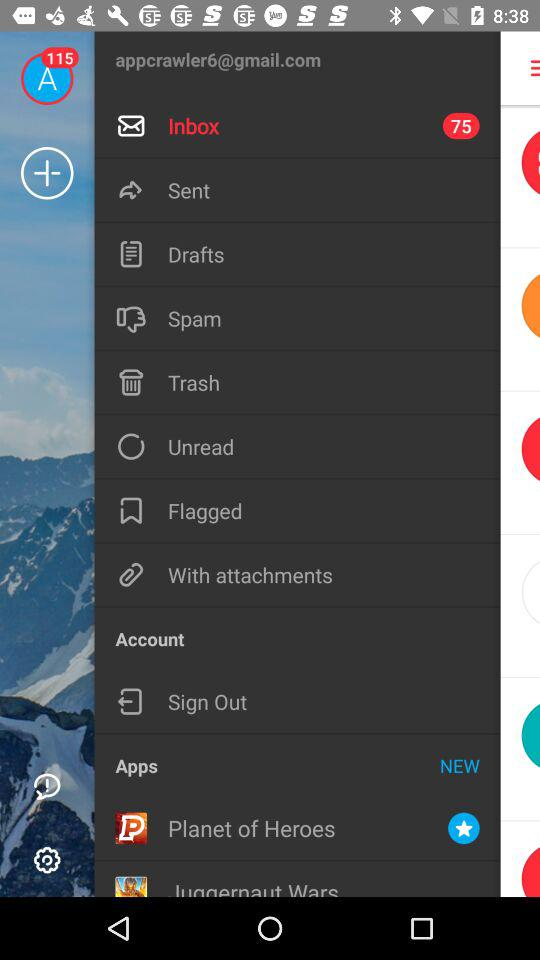Which application is new? The new application is "Planet of Heroes". 